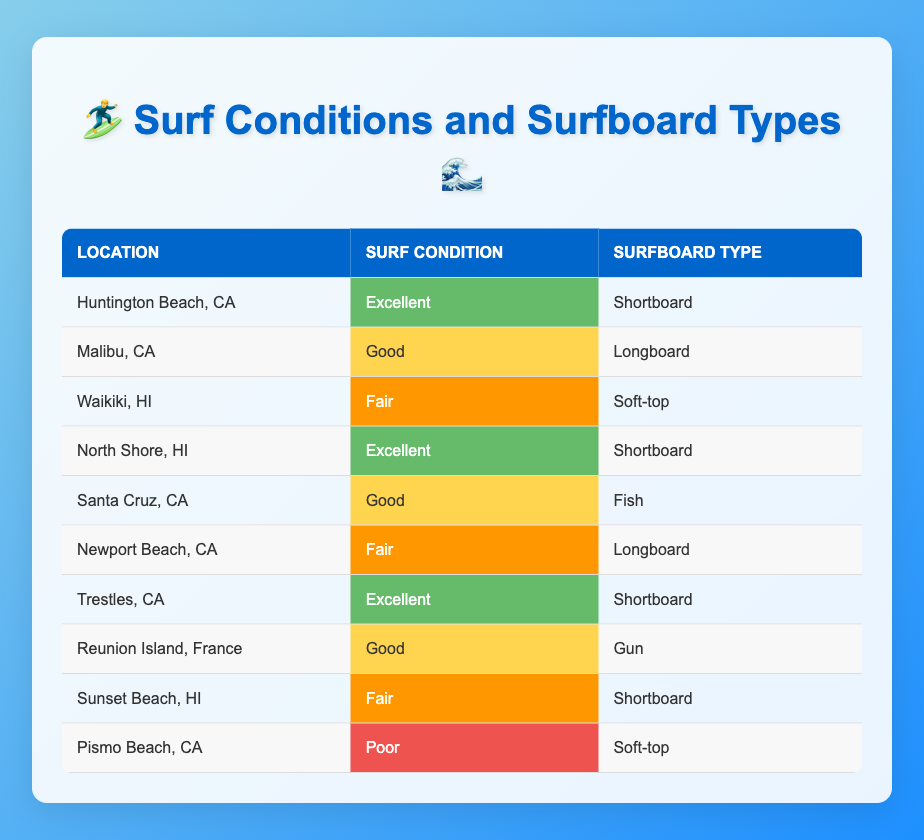What surf condition rating is associated with Huntington Beach, CA? The table lists Huntington Beach, CA under the "Surf Condition Rating" column, showing that the rating is "Excellent".
Answer: Excellent How many locations have a "Good" surf condition rating? By reviewing the table, we find Malibu, CA (Good), Santa Cruz, CA (Good), and Reunion Island, France (Good), totaling 3 locations.
Answer: 3 Is there any location with a "Poor" surf condition rating? The table features Pismo Beach, CA with a listing under "Surf Condition Rating" as "Poor", confirming that there is at least one such location.
Answer: Yes What type of surfboard is most commonly associated with an "Excellent" surf condition rating? A review of the table reveals that "Shortboard" appears in the surfboard type column for locations with "Excellent" conditions (Huntington Beach, North Shore, and Trestles), which makes it the most common board type in this category.
Answer: Shortboard What is the total number of different surfboard types represented in the table? The surfboard types listed are Shortboard, Longboard, Soft-top, Fish, and Gun. Five unique surfboard types are present in total when counted.
Answer: 5 How many locations have a "Fair" surf condition rating and a Soft-top surfboard? The table indicates that Waikiki, HI has a "Fair" rating with a Soft-top surfboard, while Sunset Beach, HI has a "Fair" rating but uses a Shortboard, resulting in only one location with both conditions.
Answer: 1 What surf condition rating has the highest presence in the data? Analyzing the occurrences in each category, "Excellent" is represented 3 times, "Good" 3 times, "Fair" 3 times, and "Poor" once. Therefore, while "Excellent", "Good", and "Fair" are tied, none exceeds the others.
Answer: Tied (3 times each) Are there any locations where "Shortboard" is used with a "Poor" surf condition rating? The table displays Pismo Beach, CA with a "Poor" rating but indicates the use of a Soft-top, not a Shortboard, confirming that no location has both of these attributes.
Answer: No 